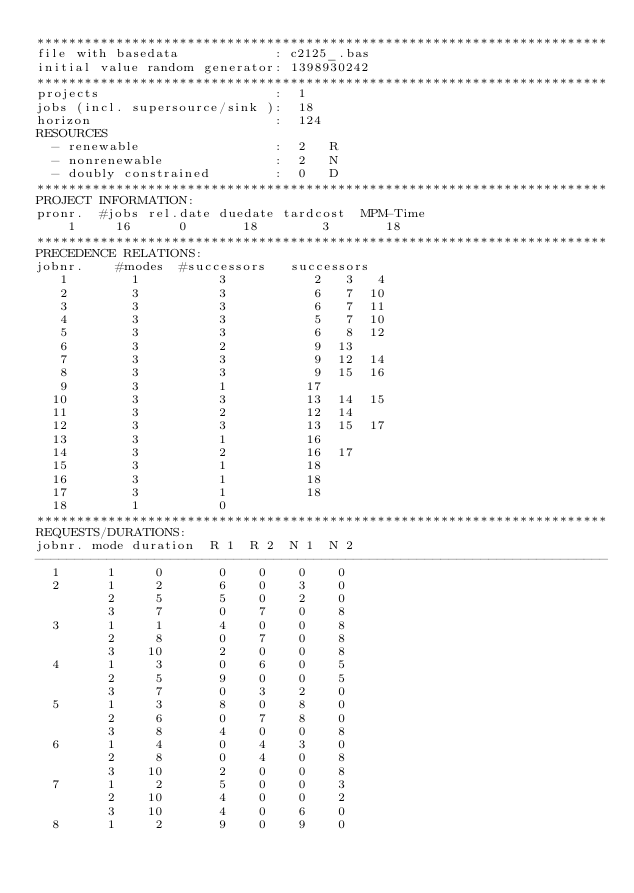<code> <loc_0><loc_0><loc_500><loc_500><_ObjectiveC_>************************************************************************
file with basedata            : c2125_.bas
initial value random generator: 1398930242
************************************************************************
projects                      :  1
jobs (incl. supersource/sink ):  18
horizon                       :  124
RESOURCES
  - renewable                 :  2   R
  - nonrenewable              :  2   N
  - doubly constrained        :  0   D
************************************************************************
PROJECT INFORMATION:
pronr.  #jobs rel.date duedate tardcost  MPM-Time
    1     16      0       18        3       18
************************************************************************
PRECEDENCE RELATIONS:
jobnr.    #modes  #successors   successors
   1        1          3           2   3   4
   2        3          3           6   7  10
   3        3          3           6   7  11
   4        3          3           5   7  10
   5        3          3           6   8  12
   6        3          2           9  13
   7        3          3           9  12  14
   8        3          3           9  15  16
   9        3          1          17
  10        3          3          13  14  15
  11        3          2          12  14
  12        3          3          13  15  17
  13        3          1          16
  14        3          2          16  17
  15        3          1          18
  16        3          1          18
  17        3          1          18
  18        1          0        
************************************************************************
REQUESTS/DURATIONS:
jobnr. mode duration  R 1  R 2  N 1  N 2
------------------------------------------------------------------------
  1      1     0       0    0    0    0
  2      1     2       6    0    3    0
         2     5       5    0    2    0
         3     7       0    7    0    8
  3      1     1       4    0    0    8
         2     8       0    7    0    8
         3    10       2    0    0    8
  4      1     3       0    6    0    5
         2     5       9    0    0    5
         3     7       0    3    2    0
  5      1     3       8    0    8    0
         2     6       0    7    8    0
         3     8       4    0    0    8
  6      1     4       0    4    3    0
         2     8       0    4    0    8
         3    10       2    0    0    8
  7      1     2       5    0    0    3
         2    10       4    0    0    2
         3    10       4    0    6    0
  8      1     2       9    0    9    0</code> 